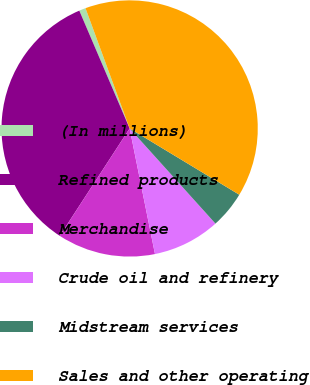Convert chart. <chart><loc_0><loc_0><loc_500><loc_500><pie_chart><fcel>(In millions)<fcel>Refined products<fcel>Merchandise<fcel>Crude oil and refinery<fcel>Midstream services<fcel>Sales and other operating<nl><fcel>0.83%<fcel>34.39%<fcel>12.35%<fcel>8.51%<fcel>4.67%<fcel>39.25%<nl></chart> 